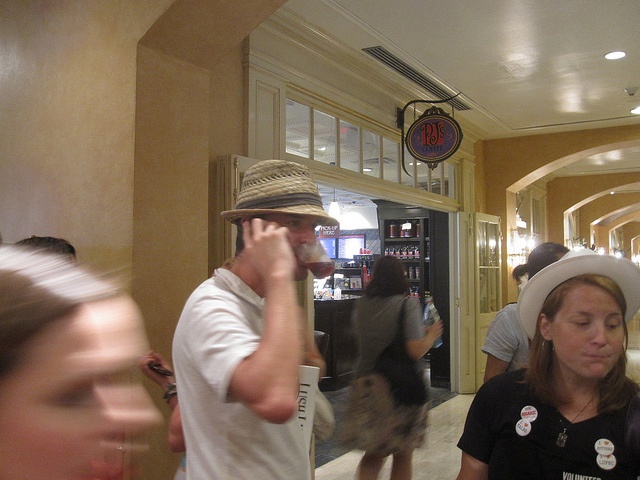Describe the objects in this image and their specific colors. I can see people in gray and darkgray tones, people in gray, brown, tan, and lightgray tones, people in gray, black, brown, and maroon tones, people in gray, black, and maroon tones, and people in gray, black, and darkgray tones in this image. 